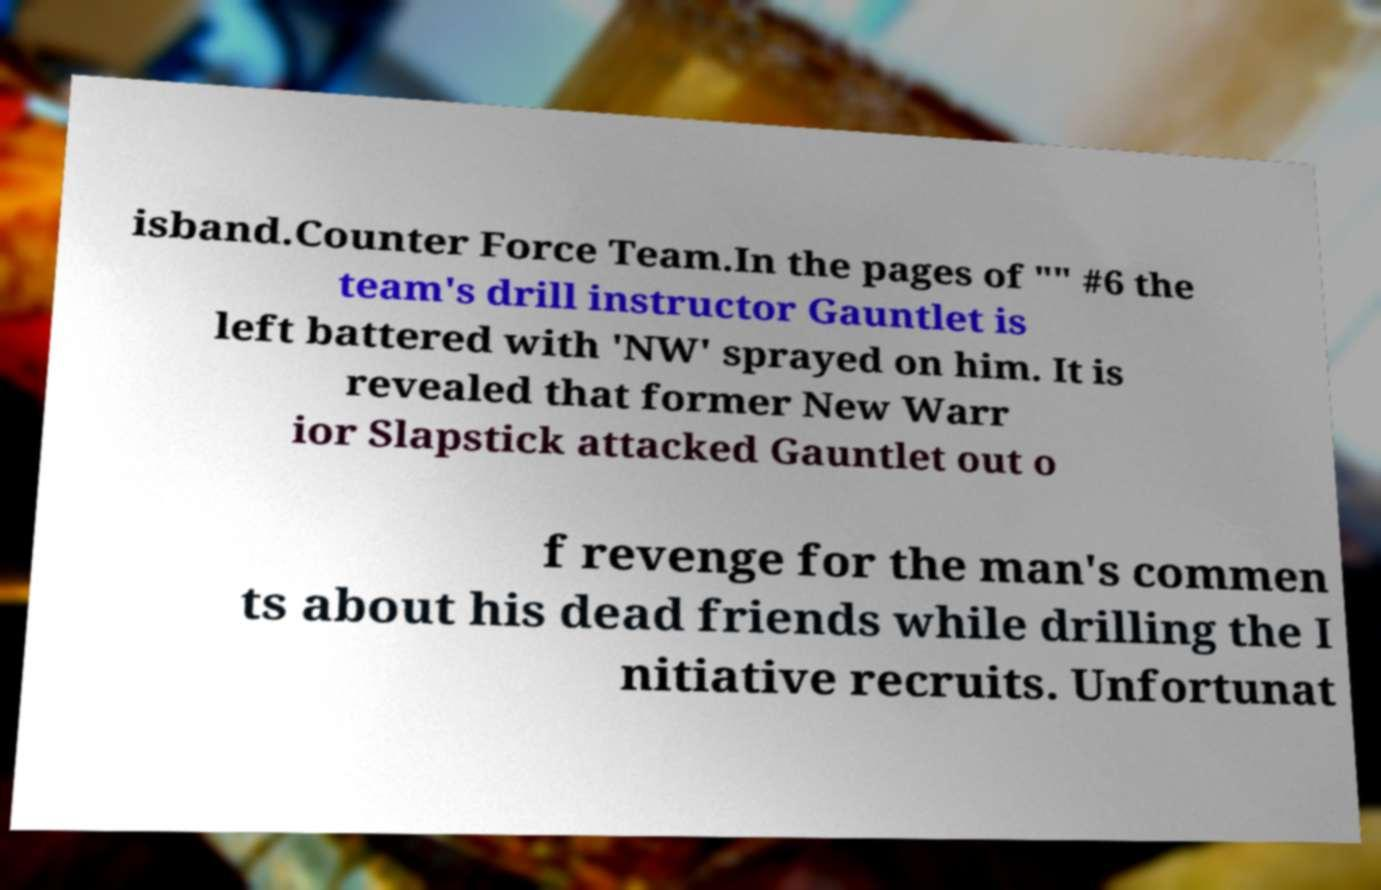For documentation purposes, I need the text within this image transcribed. Could you provide that? isband.Counter Force Team.In the pages of "" #6 the team's drill instructor Gauntlet is left battered with 'NW' sprayed on him. It is revealed that former New Warr ior Slapstick attacked Gauntlet out o f revenge for the man's commen ts about his dead friends while drilling the I nitiative recruits. Unfortunat 